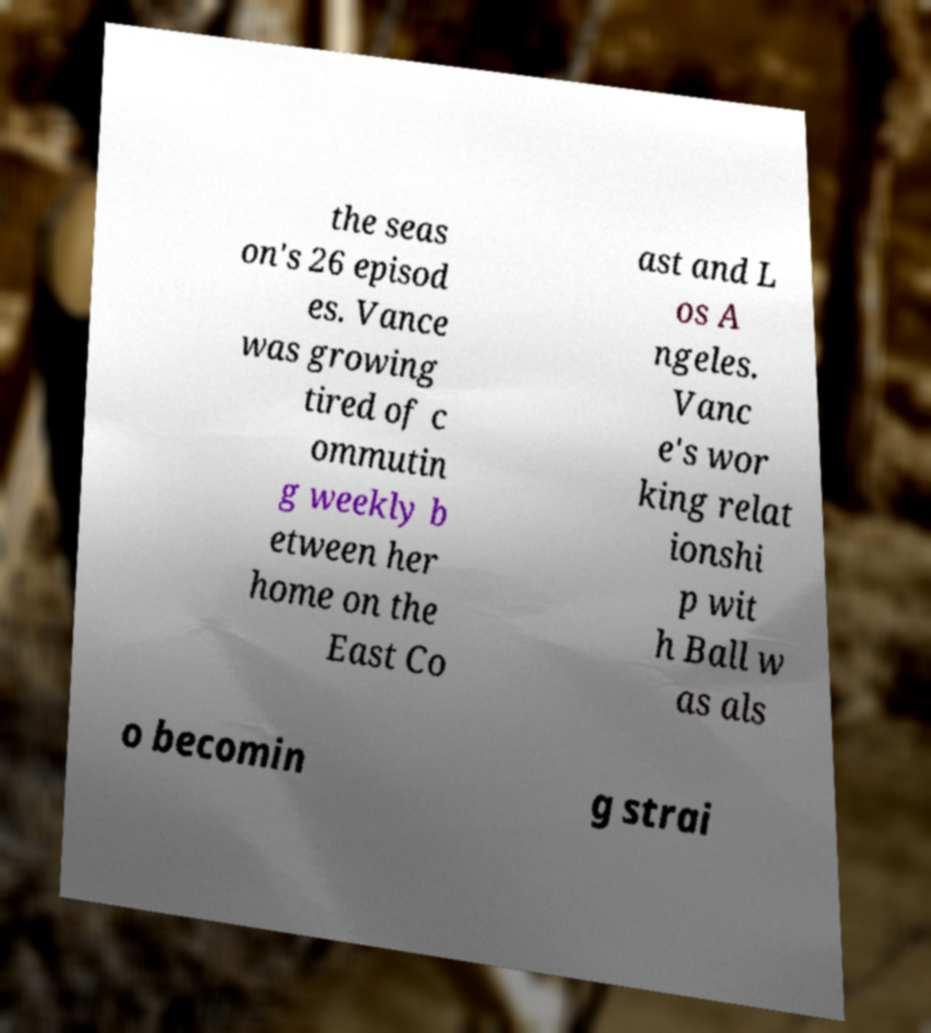I need the written content from this picture converted into text. Can you do that? the seas on's 26 episod es. Vance was growing tired of c ommutin g weekly b etween her home on the East Co ast and L os A ngeles. Vanc e's wor king relat ionshi p wit h Ball w as als o becomin g strai 